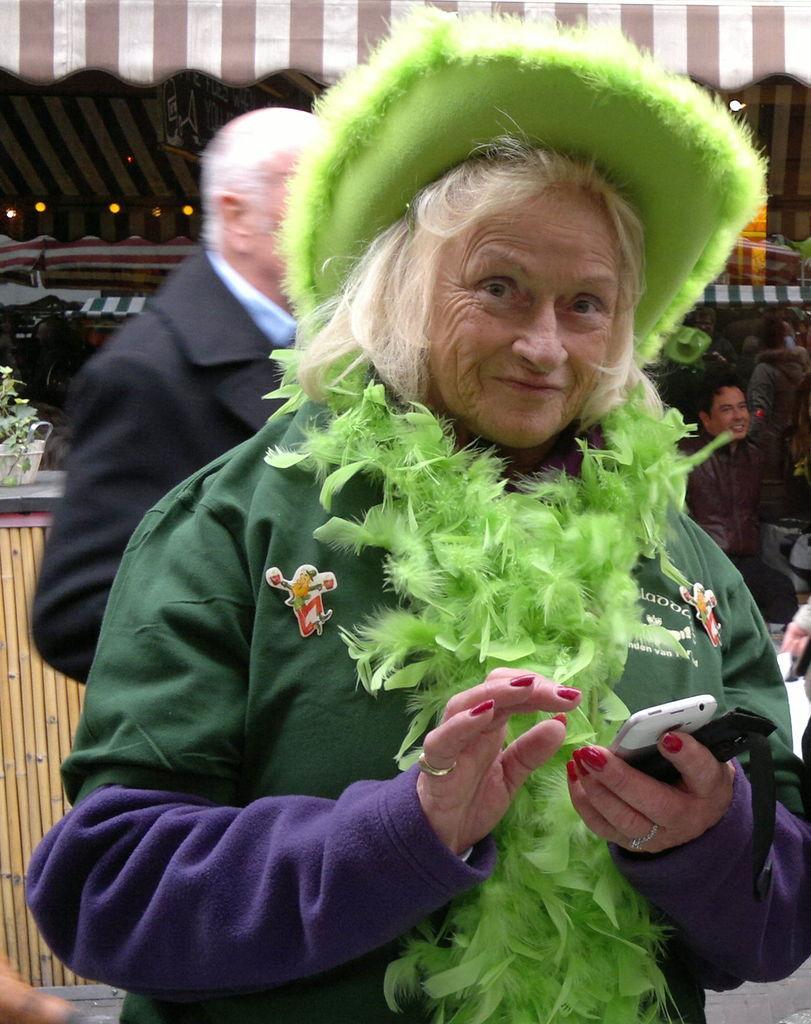How would you summarize this image in a sentence or two? There is a woman in thick green color jacket, holding a mobile, smiling and standing. In the background, there is another person in black color shirt, standing, there is another person sitting on a chair and smiling, there is a pot plant on the wooden wall, there is a tent and other objects. 